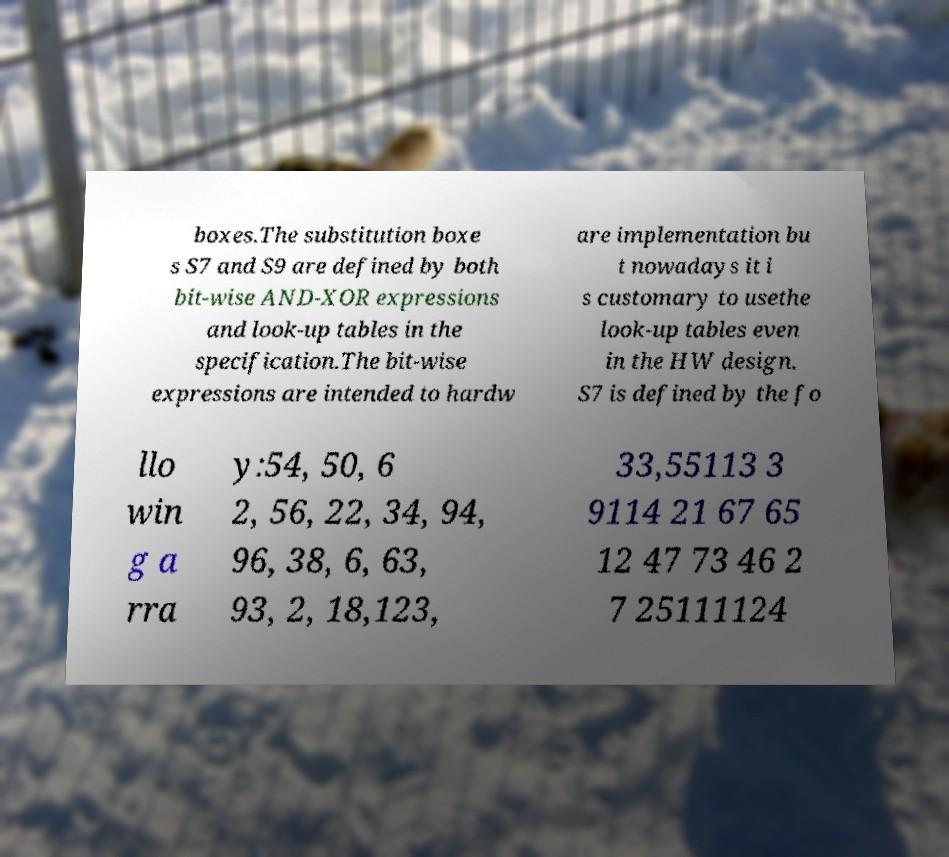Could you extract and type out the text from this image? boxes.The substitution boxe s S7 and S9 are defined by both bit-wise AND-XOR expressions and look-up tables in the specification.The bit-wise expressions are intended to hardw are implementation bu t nowadays it i s customary to usethe look-up tables even in the HW design. S7 is defined by the fo llo win g a rra y:54, 50, 6 2, 56, 22, 34, 94, 96, 38, 6, 63, 93, 2, 18,123, 33,55113 3 9114 21 67 65 12 47 73 46 2 7 25111124 